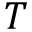Convert formula to latex. <formula><loc_0><loc_0><loc_500><loc_500>T</formula> 